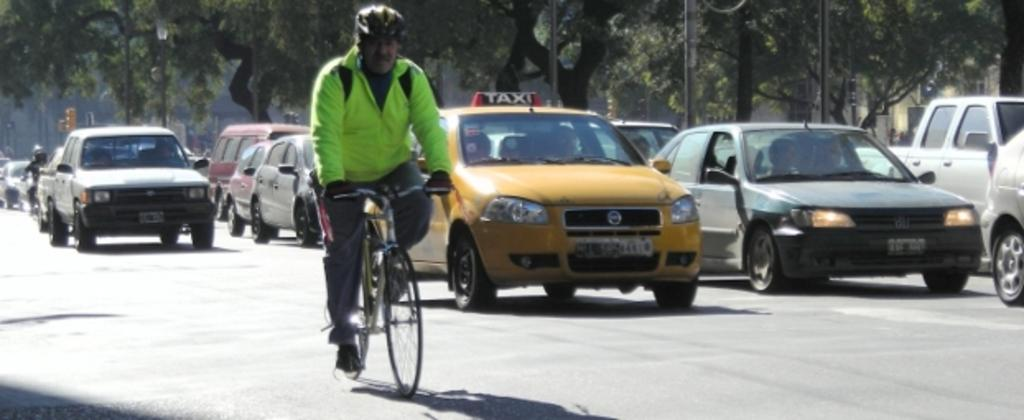Provide a one-sentence caption for the provided image. a taxi cab with the word taxi at the top. 